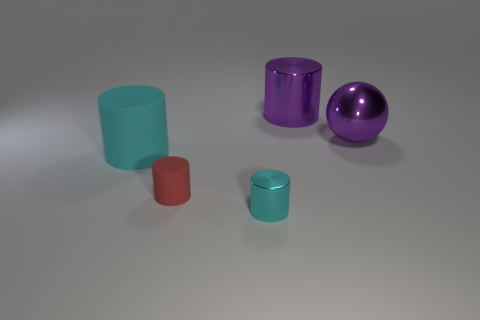Add 2 big rubber things. How many objects exist? 7 Subtract all cylinders. How many objects are left? 1 Add 2 tiny objects. How many tiny objects are left? 4 Add 5 brown blocks. How many brown blocks exist? 5 Subtract 0 yellow cubes. How many objects are left? 5 Subtract all small cyan matte objects. Subtract all shiny spheres. How many objects are left? 4 